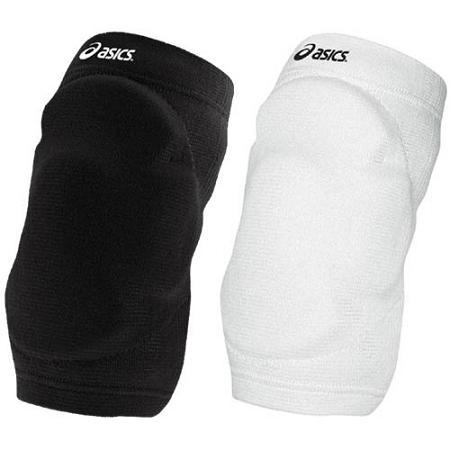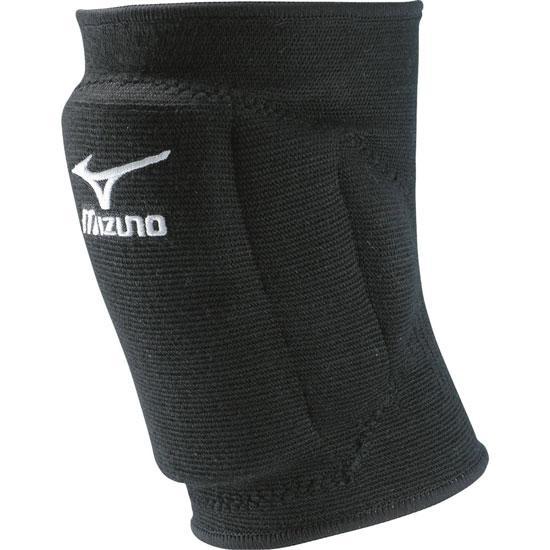The first image is the image on the left, the second image is the image on the right. Evaluate the accuracy of this statement regarding the images: "One of the images features a knee pad still in its red packaging". Is it true? Answer yes or no. No. The first image is the image on the left, the second image is the image on the right. Given the left and right images, does the statement "One of the images shows exactly two knee braces." hold true? Answer yes or no. Yes. 